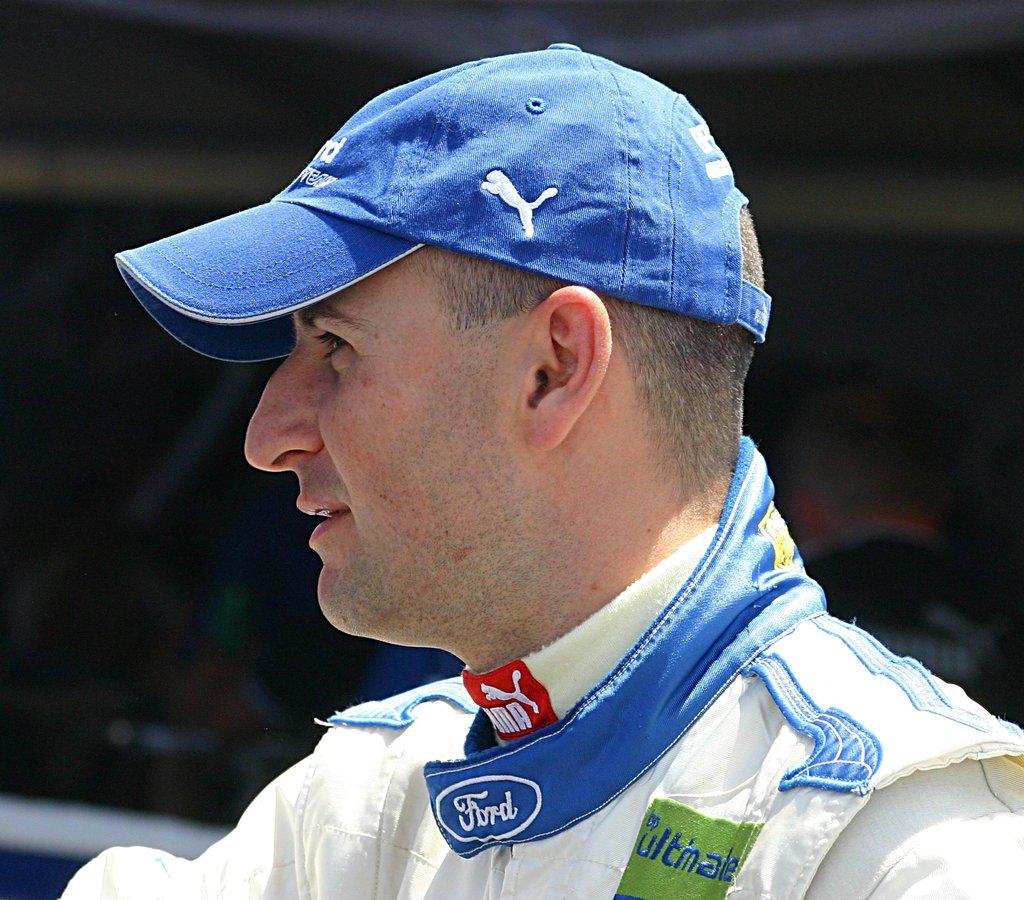What car maker is on the man's collar?
Keep it short and to the point. Ford. Is puma one of his sponsors?
Provide a short and direct response. Yes. 